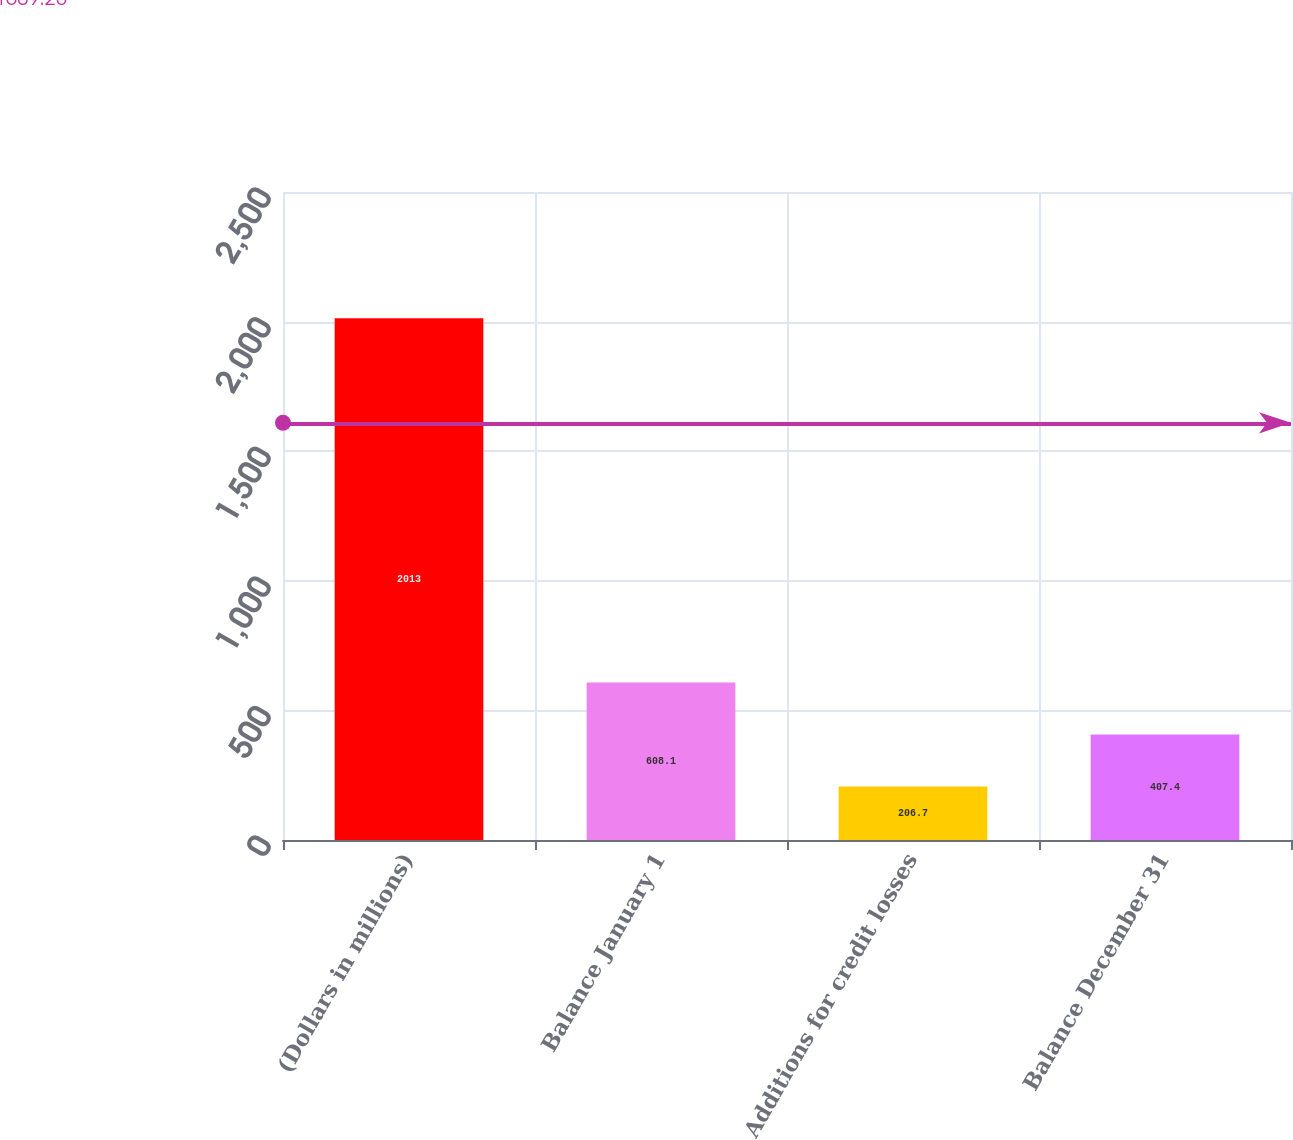<chart> <loc_0><loc_0><loc_500><loc_500><bar_chart><fcel>(Dollars in millions)<fcel>Balance January 1<fcel>Additions for credit losses<fcel>Balance December 31<nl><fcel>2013<fcel>608.1<fcel>206.7<fcel>407.4<nl></chart> 